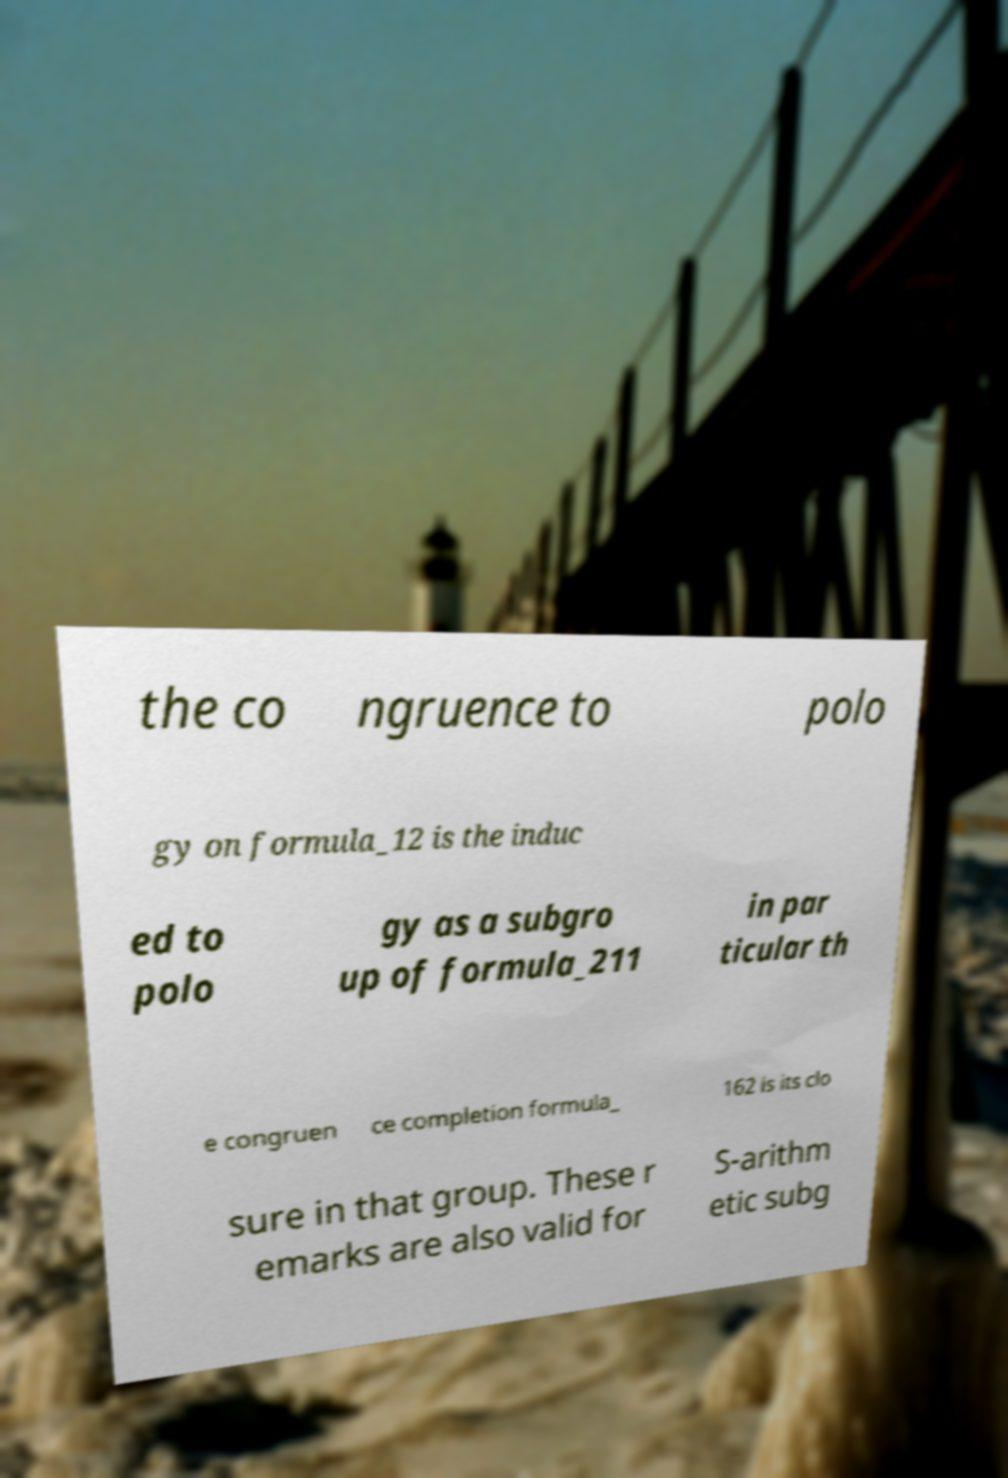Can you read and provide the text displayed in the image?This photo seems to have some interesting text. Can you extract and type it out for me? the co ngruence to polo gy on formula_12 is the induc ed to polo gy as a subgro up of formula_211 in par ticular th e congruen ce completion formula_ 162 is its clo sure in that group. These r emarks are also valid for S-arithm etic subg 